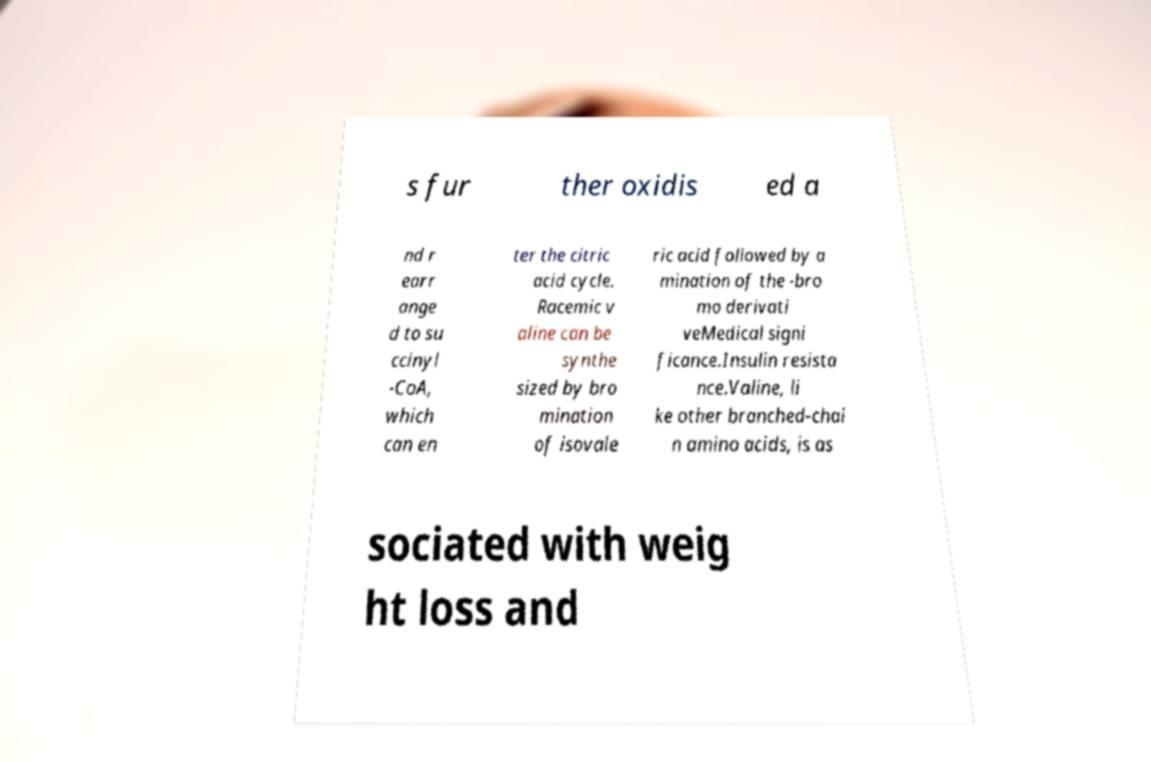For documentation purposes, I need the text within this image transcribed. Could you provide that? s fur ther oxidis ed a nd r earr ange d to su ccinyl -CoA, which can en ter the citric acid cycle. Racemic v aline can be synthe sized by bro mination of isovale ric acid followed by a mination of the -bro mo derivati veMedical signi ficance.Insulin resista nce.Valine, li ke other branched-chai n amino acids, is as sociated with weig ht loss and 